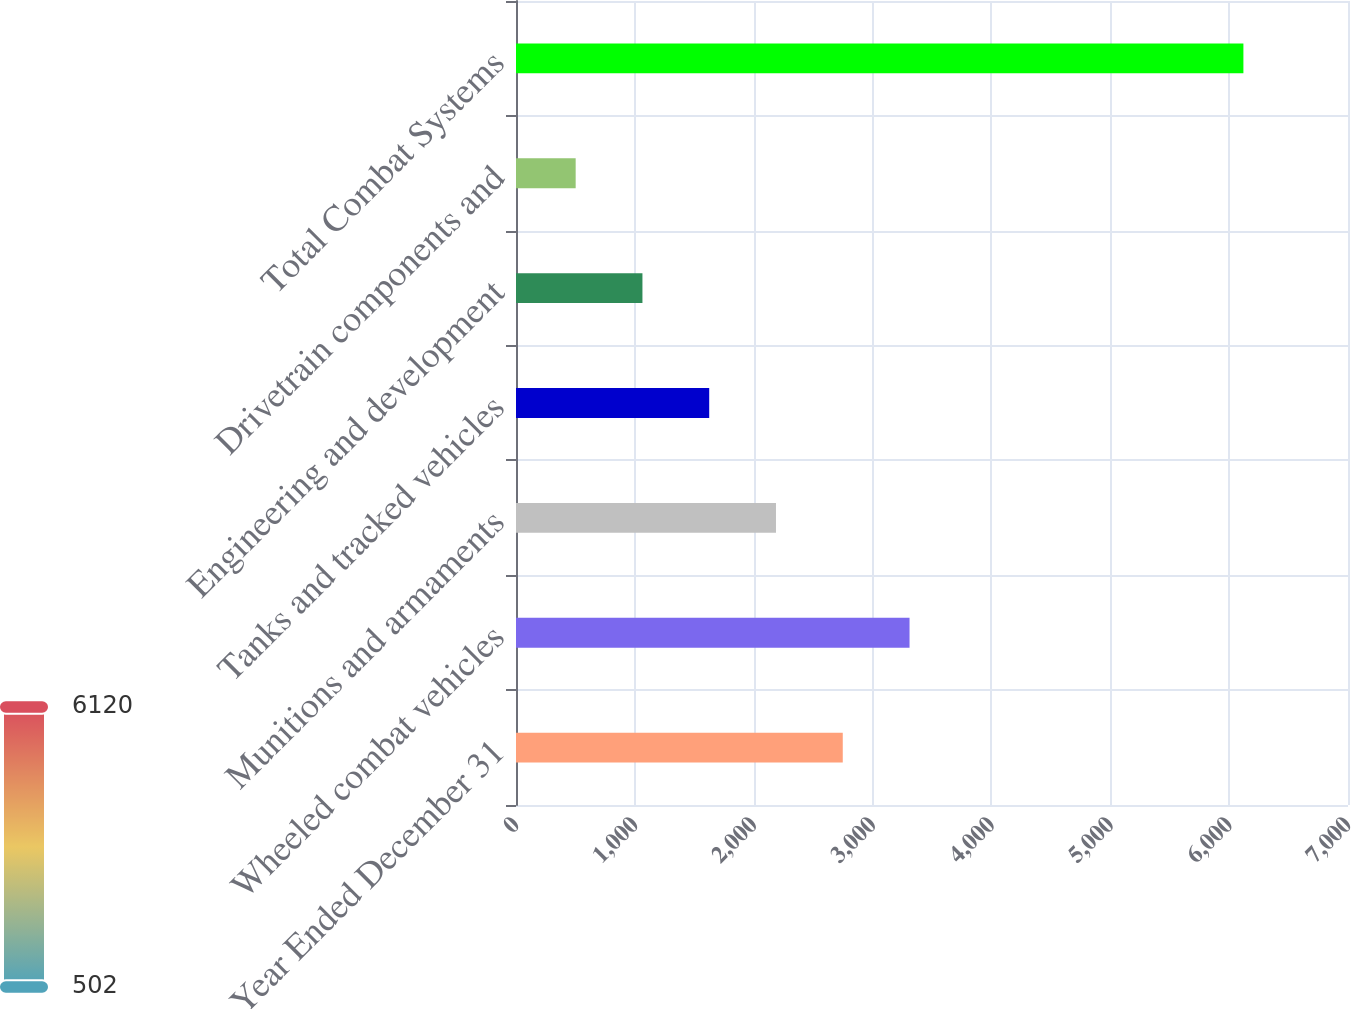<chart> <loc_0><loc_0><loc_500><loc_500><bar_chart><fcel>Year Ended December 31<fcel>Wheeled combat vehicles<fcel>Munitions and armaments<fcel>Tanks and tracked vehicles<fcel>Engineering and development<fcel>Drivetrain components and<fcel>Total Combat Systems<nl><fcel>2749.2<fcel>3311<fcel>2187.4<fcel>1625.6<fcel>1063.8<fcel>502<fcel>6120<nl></chart> 